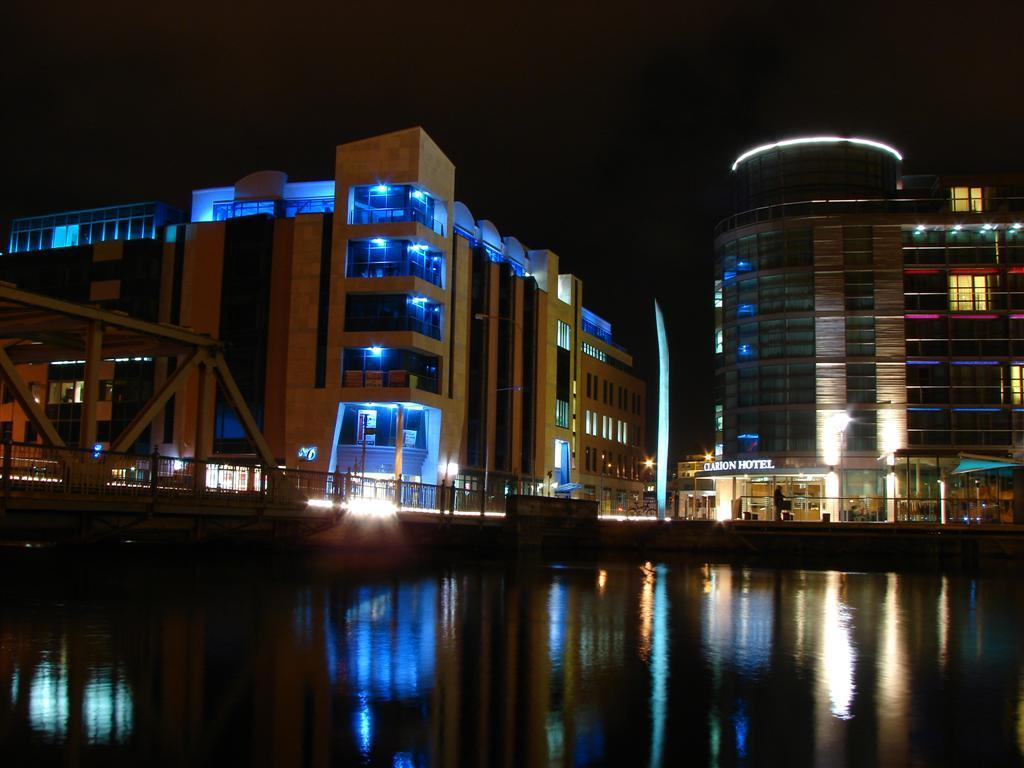What type of structures can be seen in the image? There are buildings in the image. What type of man-made structure connects two areas in the image? There is a bridge in the image. What type of barrier can be seen in the image? There are fences in the image. What can be seen reflecting off the water in the image? There are reflections of buildings in the water. What type of punishment is the queen giving to the dogs in the image? There is no queen, dogs, or punishment present in the image. 